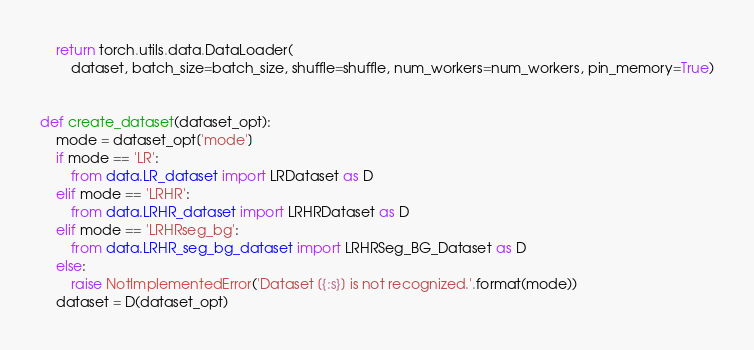<code> <loc_0><loc_0><loc_500><loc_500><_Python_>    return torch.utils.data.DataLoader(
        dataset, batch_size=batch_size, shuffle=shuffle, num_workers=num_workers, pin_memory=True)


def create_dataset(dataset_opt):
    mode = dataset_opt['mode']
    if mode == 'LR':
        from data.LR_dataset import LRDataset as D
    elif mode == 'LRHR':
        from data.LRHR_dataset import LRHRDataset as D
    elif mode == 'LRHRseg_bg':
        from data.LRHR_seg_bg_dataset import LRHRSeg_BG_Dataset as D
    else:
        raise NotImplementedError('Dataset [{:s}] is not recognized.'.format(mode))
    dataset = D(dataset_opt)</code> 